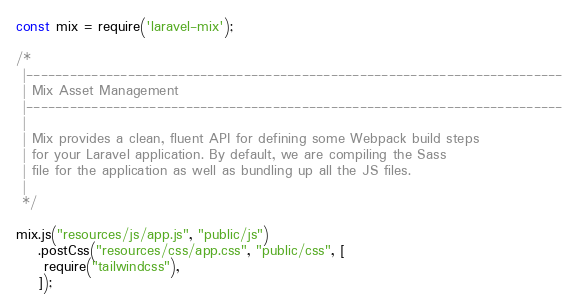Convert code to text. <code><loc_0><loc_0><loc_500><loc_500><_JavaScript_>const mix = require('laravel-mix');

/*
 |--------------------------------------------------------------------------
 | Mix Asset Management
 |--------------------------------------------------------------------------
 |
 | Mix provides a clean, fluent API for defining some Webpack build steps
 | for your Laravel application. By default, we are compiling the Sass
 | file for the application as well as bundling up all the JS files.
 |
 */

mix.js("resources/js/app.js", "public/js")
    .postCss("resources/css/app.css", "public/css", [
     require("tailwindcss"),
    ]);</code> 